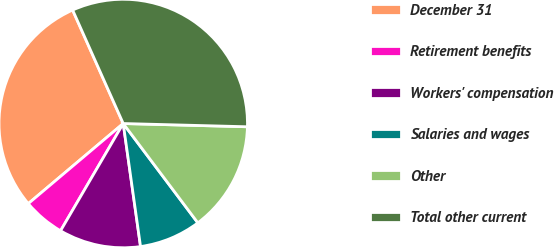Convert chart to OTSL. <chart><loc_0><loc_0><loc_500><loc_500><pie_chart><fcel>December 31<fcel>Retirement benefits<fcel>Workers' compensation<fcel>Salaries and wages<fcel>Other<fcel>Total other current<nl><fcel>29.48%<fcel>5.43%<fcel>10.64%<fcel>8.03%<fcel>14.33%<fcel>32.09%<nl></chart> 